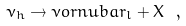<formula> <loc_0><loc_0><loc_500><loc_500>\nu _ { h } \to \nu o r n u b a r _ { l } + X \ ,</formula> 